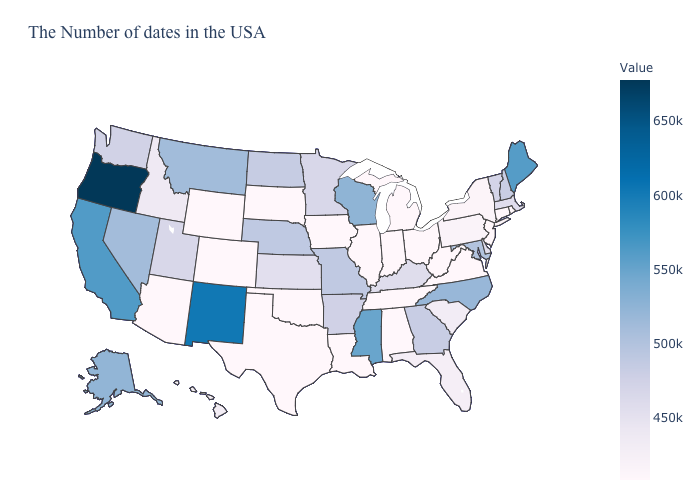Does the map have missing data?
Be succinct. No. Which states have the lowest value in the MidWest?
Be succinct. Ohio, Michigan, Indiana, Illinois, Iowa, South Dakota. 